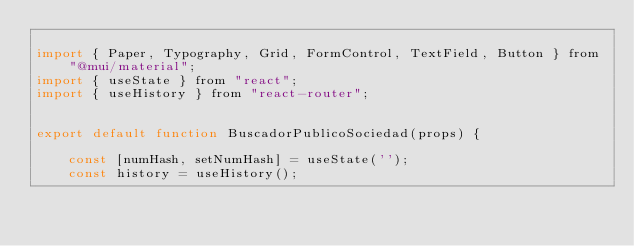<code> <loc_0><loc_0><loc_500><loc_500><_JavaScript_>
import { Paper, Typography, Grid, FormControl, TextField, Button } from "@mui/material";
import { useState } from "react";
import { useHistory } from "react-router";


export default function BuscadorPublicoSociedad(props) {

    const [numHash, setNumHash] = useState('');
    const history = useHistory();
</code> 